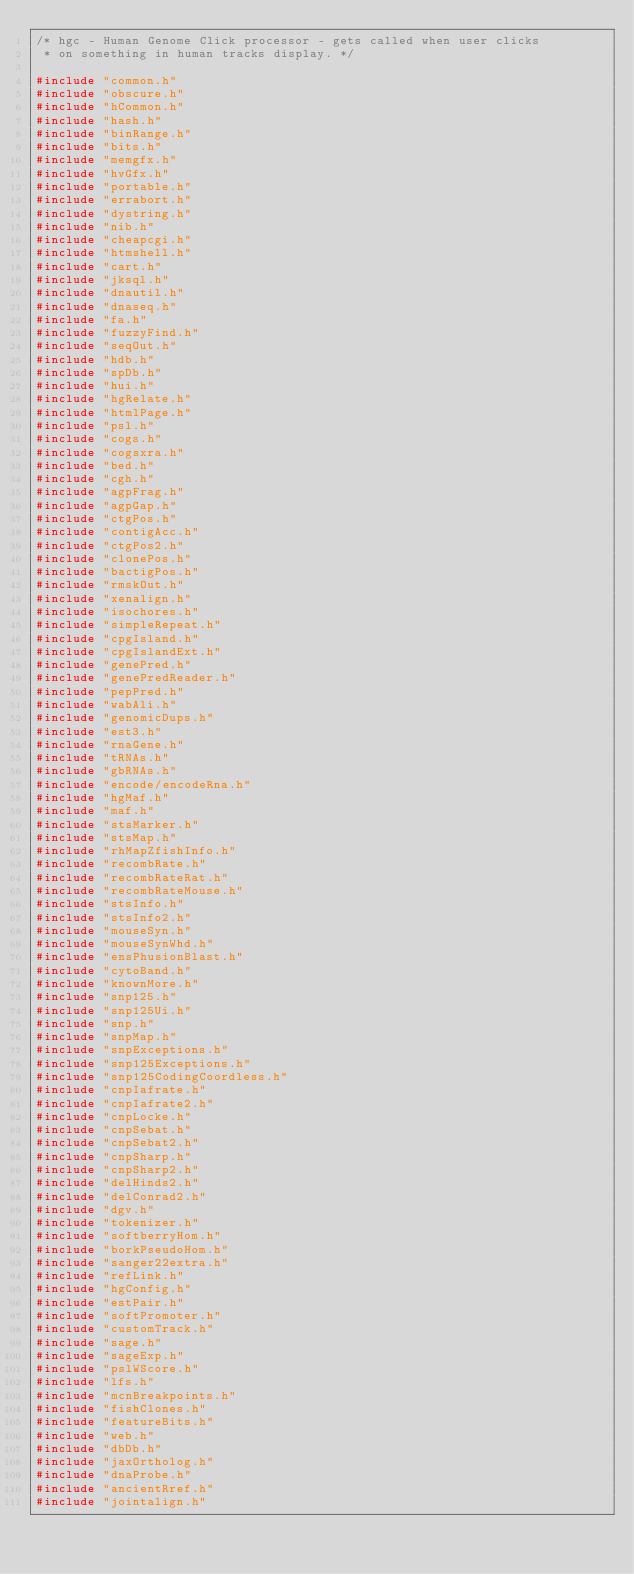Convert code to text. <code><loc_0><loc_0><loc_500><loc_500><_C_>/* hgc - Human Genome Click processor - gets called when user clicks
 * on something in human tracks display. */

#include "common.h"
#include "obscure.h"
#include "hCommon.h"
#include "hash.h"
#include "binRange.h"
#include "bits.h"
#include "memgfx.h"
#include "hvGfx.h"
#include "portable.h"
#include "errabort.h"
#include "dystring.h"
#include "nib.h"
#include "cheapcgi.h"
#include "htmshell.h"
#include "cart.h"
#include "jksql.h"
#include "dnautil.h"
#include "dnaseq.h"
#include "fa.h"
#include "fuzzyFind.h"
#include "seqOut.h"
#include "hdb.h"
#include "spDb.h"
#include "hui.h"
#include "hgRelate.h"
#include "htmlPage.h"
#include "psl.h"
#include "cogs.h"
#include "cogsxra.h"
#include "bed.h"
#include "cgh.h"
#include "agpFrag.h"
#include "agpGap.h"
#include "ctgPos.h"
#include "contigAcc.h"
#include "ctgPos2.h"
#include "clonePos.h"
#include "bactigPos.h"
#include "rmskOut.h"
#include "xenalign.h"
#include "isochores.h"
#include "simpleRepeat.h"
#include "cpgIsland.h"
#include "cpgIslandExt.h"
#include "genePred.h"
#include "genePredReader.h"
#include "pepPred.h"
#include "wabAli.h"
#include "genomicDups.h"
#include "est3.h"
#include "rnaGene.h"
#include "tRNAs.h"
#include "gbRNAs.h"
#include "encode/encodeRna.h"
#include "hgMaf.h"
#include "maf.h"
#include "stsMarker.h"
#include "stsMap.h"
#include "rhMapZfishInfo.h"
#include "recombRate.h"
#include "recombRateRat.h"
#include "recombRateMouse.h"
#include "stsInfo.h"
#include "stsInfo2.h"
#include "mouseSyn.h"
#include "mouseSynWhd.h"
#include "ensPhusionBlast.h"
#include "cytoBand.h"
#include "knownMore.h"
#include "snp125.h"
#include "snp125Ui.h"
#include "snp.h"
#include "snpMap.h"
#include "snpExceptions.h"
#include "snp125Exceptions.h"
#include "snp125CodingCoordless.h"
#include "cnpIafrate.h"
#include "cnpIafrate2.h"
#include "cnpLocke.h"
#include "cnpSebat.h"
#include "cnpSebat2.h"
#include "cnpSharp.h"
#include "cnpSharp2.h"
#include "delHinds2.h"
#include "delConrad2.h"
#include "dgv.h"
#include "tokenizer.h"
#include "softberryHom.h"
#include "borkPseudoHom.h"
#include "sanger22extra.h"
#include "refLink.h"
#include "hgConfig.h"
#include "estPair.h"
#include "softPromoter.h"
#include "customTrack.h"
#include "sage.h"
#include "sageExp.h"
#include "pslWScore.h"
#include "lfs.h"
#include "mcnBreakpoints.h"
#include "fishClones.h"
#include "featureBits.h"
#include "web.h"
#include "dbDb.h"
#include "jaxOrtholog.h"
#include "dnaProbe.h"
#include "ancientRref.h"
#include "jointalign.h"</code> 